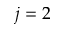<formula> <loc_0><loc_0><loc_500><loc_500>j = 2</formula> 